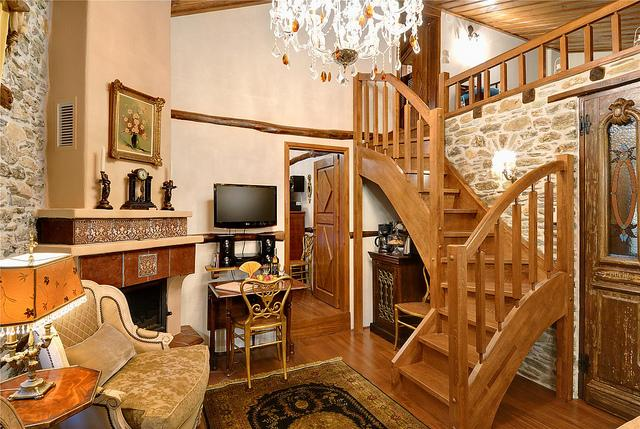What form of heating is used here? Please explain your reasoning. wood. Below there is a chimney on the wall. 